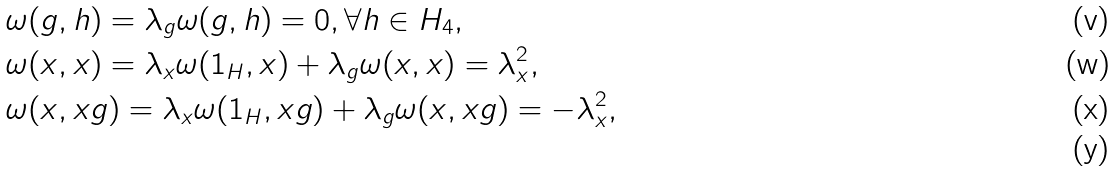<formula> <loc_0><loc_0><loc_500><loc_500>& \omega ( g , h ) = \lambda _ { g } \omega ( g , h ) = 0 , \forall h \in H _ { 4 } , \\ & \omega ( x , x ) = \lambda _ { x } \omega ( 1 _ { H } , x ) + \lambda _ { g } \omega ( x , x ) = \lambda _ { x } ^ { 2 } , \\ & \omega ( x , x g ) = \lambda _ { x } \omega ( 1 _ { H } , x g ) + \lambda _ { g } \omega ( x , x g ) = - \lambda _ { x } ^ { 2 } , \\</formula> 